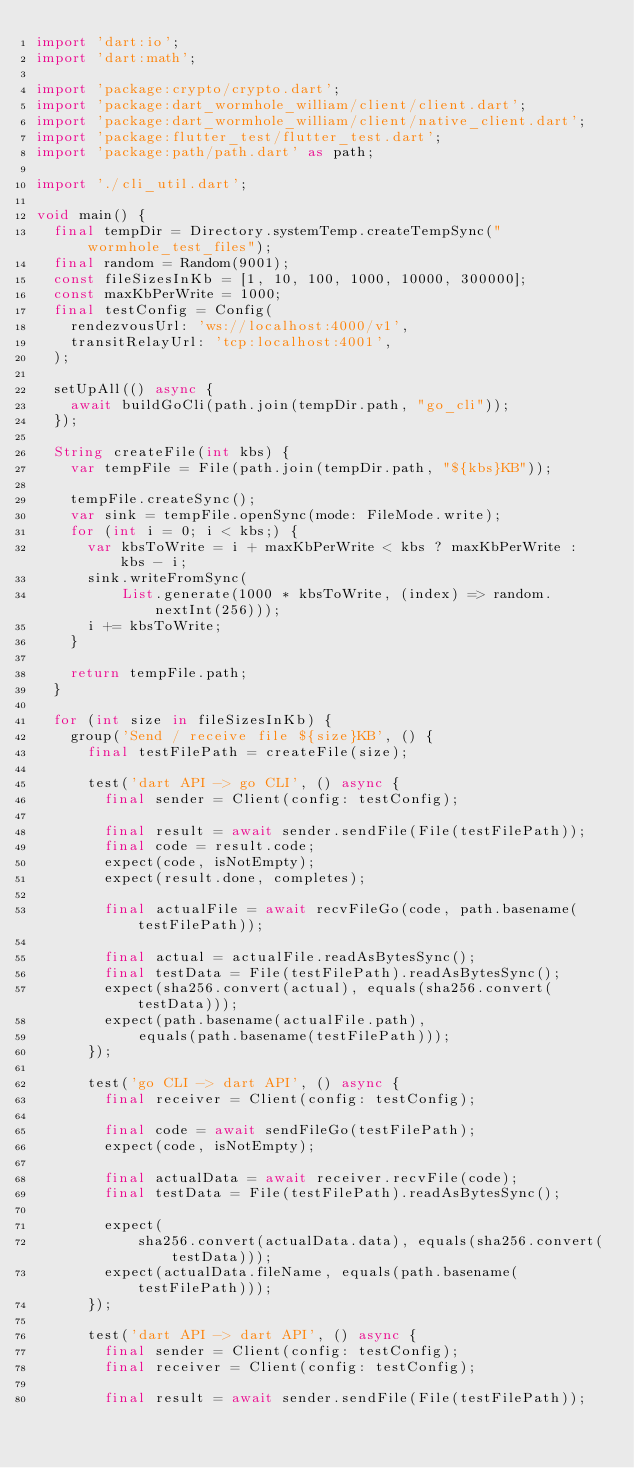Convert code to text. <code><loc_0><loc_0><loc_500><loc_500><_Dart_>import 'dart:io';
import 'dart:math';

import 'package:crypto/crypto.dart';
import 'package:dart_wormhole_william/client/client.dart';
import 'package:dart_wormhole_william/client/native_client.dart';
import 'package:flutter_test/flutter_test.dart';
import 'package:path/path.dart' as path;

import './cli_util.dart';

void main() {
  final tempDir = Directory.systemTemp.createTempSync("wormhole_test_files");
  final random = Random(9001);
  const fileSizesInKb = [1, 10, 100, 1000, 10000, 300000];
  const maxKbPerWrite = 1000;
  final testConfig = Config(
    rendezvousUrl: 'ws://localhost:4000/v1',
    transitRelayUrl: 'tcp:localhost:4001',
  );

  setUpAll(() async {
    await buildGoCli(path.join(tempDir.path, "go_cli"));
  });

  String createFile(int kbs) {
    var tempFile = File(path.join(tempDir.path, "${kbs}KB"));

    tempFile.createSync();
    var sink = tempFile.openSync(mode: FileMode.write);
    for (int i = 0; i < kbs;) {
      var kbsToWrite = i + maxKbPerWrite < kbs ? maxKbPerWrite : kbs - i;
      sink.writeFromSync(
          List.generate(1000 * kbsToWrite, (index) => random.nextInt(256)));
      i += kbsToWrite;
    }

    return tempFile.path;
  }

  for (int size in fileSizesInKb) {
    group('Send / receive file ${size}KB', () {
      final testFilePath = createFile(size);

      test('dart API -> go CLI', () async {
        final sender = Client(config: testConfig);

        final result = await sender.sendFile(File(testFilePath));
        final code = result.code;
        expect(code, isNotEmpty);
        expect(result.done, completes);

        final actualFile = await recvFileGo(code, path.basename(testFilePath));

        final actual = actualFile.readAsBytesSync();
        final testData = File(testFilePath).readAsBytesSync();
        expect(sha256.convert(actual), equals(sha256.convert(testData)));
        expect(path.basename(actualFile.path),
            equals(path.basename(testFilePath)));
      });

      test('go CLI -> dart API', () async {
        final receiver = Client(config: testConfig);

        final code = await sendFileGo(testFilePath);
        expect(code, isNotEmpty);

        final actualData = await receiver.recvFile(code);
        final testData = File(testFilePath).readAsBytesSync();

        expect(
            sha256.convert(actualData.data), equals(sha256.convert(testData)));
        expect(actualData.fileName, equals(path.basename(testFilePath)));
      });

      test('dart API -> dart API', () async {
        final sender = Client(config: testConfig);
        final receiver = Client(config: testConfig);

        final result = await sender.sendFile(File(testFilePath));</code> 